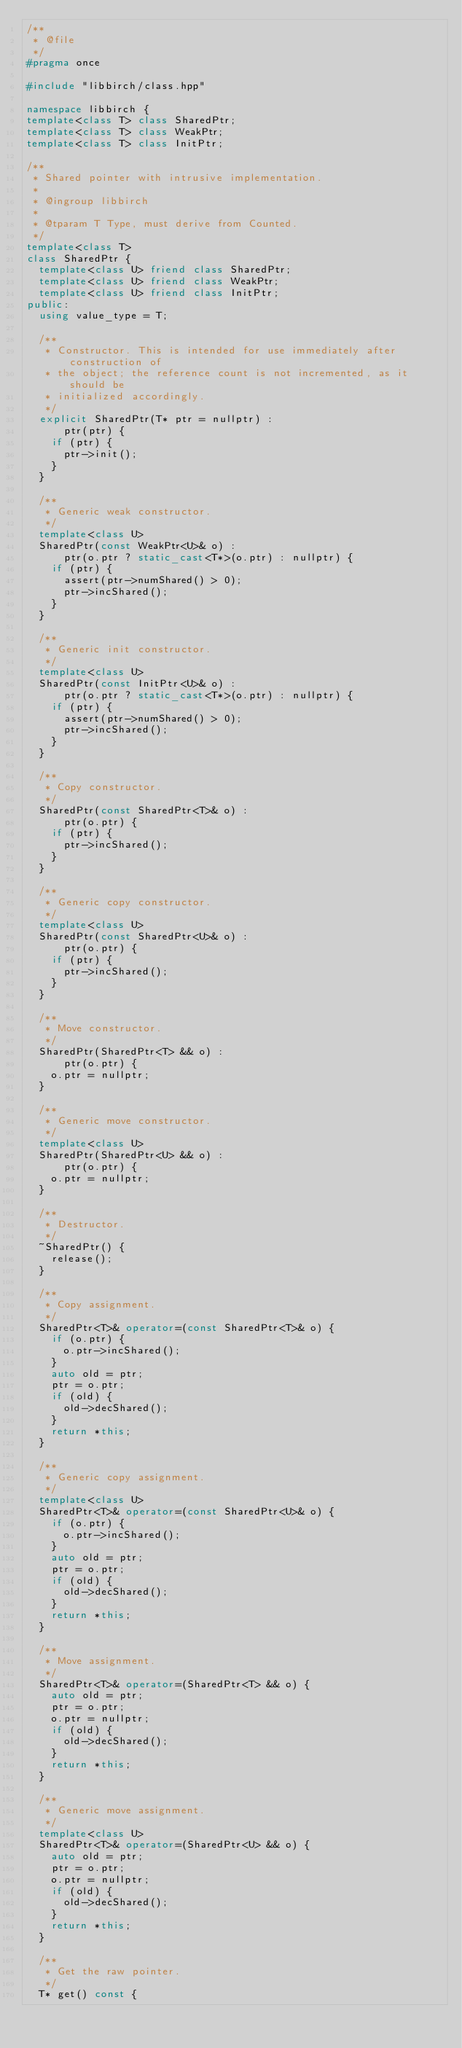Convert code to text. <code><loc_0><loc_0><loc_500><loc_500><_C++_>/**
 * @file
 */
#pragma once

#include "libbirch/class.hpp"

namespace libbirch {
template<class T> class SharedPtr;
template<class T> class WeakPtr;
template<class T> class InitPtr;

/**
 * Shared pointer with intrusive implementation.
 *
 * @ingroup libbirch
 *
 * @tparam T Type, must derive from Counted.
 */
template<class T>
class SharedPtr {
  template<class U> friend class SharedPtr;
  template<class U> friend class WeakPtr;
  template<class U> friend class InitPtr;
public:
  using value_type = T;

  /**
   * Constructor. This is intended for use immediately after construction of
   * the object; the reference count is not incremented, as it should be
   * initialized accordingly.
   */
  explicit SharedPtr(T* ptr = nullptr) :
      ptr(ptr) {
    if (ptr) {
      ptr->init();
    }
  }

  /**
   * Generic weak constructor.
   */
  template<class U>
  SharedPtr(const WeakPtr<U>& o) :
      ptr(o.ptr ? static_cast<T*>(o.ptr) : nullptr) {
    if (ptr) {
      assert(ptr->numShared() > 0);
      ptr->incShared();
    }
  }

  /**
   * Generic init constructor.
   */
  template<class U>
  SharedPtr(const InitPtr<U>& o) :
      ptr(o.ptr ? static_cast<T*>(o.ptr) : nullptr) {
    if (ptr) {
      assert(ptr->numShared() > 0);
      ptr->incShared();
    }
  }

  /**
   * Copy constructor.
   */
  SharedPtr(const SharedPtr<T>& o) :
      ptr(o.ptr) {
    if (ptr) {
      ptr->incShared();
    }
  }

  /**
   * Generic copy constructor.
   */
  template<class U>
  SharedPtr(const SharedPtr<U>& o) :
      ptr(o.ptr) {
    if (ptr) {
      ptr->incShared();
    }
  }

  /**
   * Move constructor.
   */
  SharedPtr(SharedPtr<T> && o) :
      ptr(o.ptr) {
    o.ptr = nullptr;
  }

  /**
   * Generic move constructor.
   */
  template<class U>
  SharedPtr(SharedPtr<U> && o) :
      ptr(o.ptr) {
    o.ptr = nullptr;
  }

  /**
   * Destructor.
   */
  ~SharedPtr() {
    release();
  }

  /**
   * Copy assignment.
   */
  SharedPtr<T>& operator=(const SharedPtr<T>& o) {
    if (o.ptr) {
      o.ptr->incShared();
    }
    auto old = ptr;
    ptr = o.ptr;
    if (old) {
      old->decShared();
    }
    return *this;
  }

  /**
   * Generic copy assignment.
   */
  template<class U>
  SharedPtr<T>& operator=(const SharedPtr<U>& o) {
    if (o.ptr) {
      o.ptr->incShared();
    }
    auto old = ptr;
    ptr = o.ptr;
    if (old) {
      old->decShared();
    }
    return *this;
  }

  /**
   * Move assignment.
   */
  SharedPtr<T>& operator=(SharedPtr<T> && o) {
    auto old = ptr;
    ptr = o.ptr;
    o.ptr = nullptr;
    if (old) {
      old->decShared();
    }
    return *this;
  }

  /**
   * Generic move assignment.
   */
  template<class U>
  SharedPtr<T>& operator=(SharedPtr<U> && o) {
    auto old = ptr;
    ptr = o.ptr;
    o.ptr = nullptr;
    if (old) {
      old->decShared();
    }
    return *this;
  }

  /**
   * Get the raw pointer.
   */
  T* get() const {</code> 